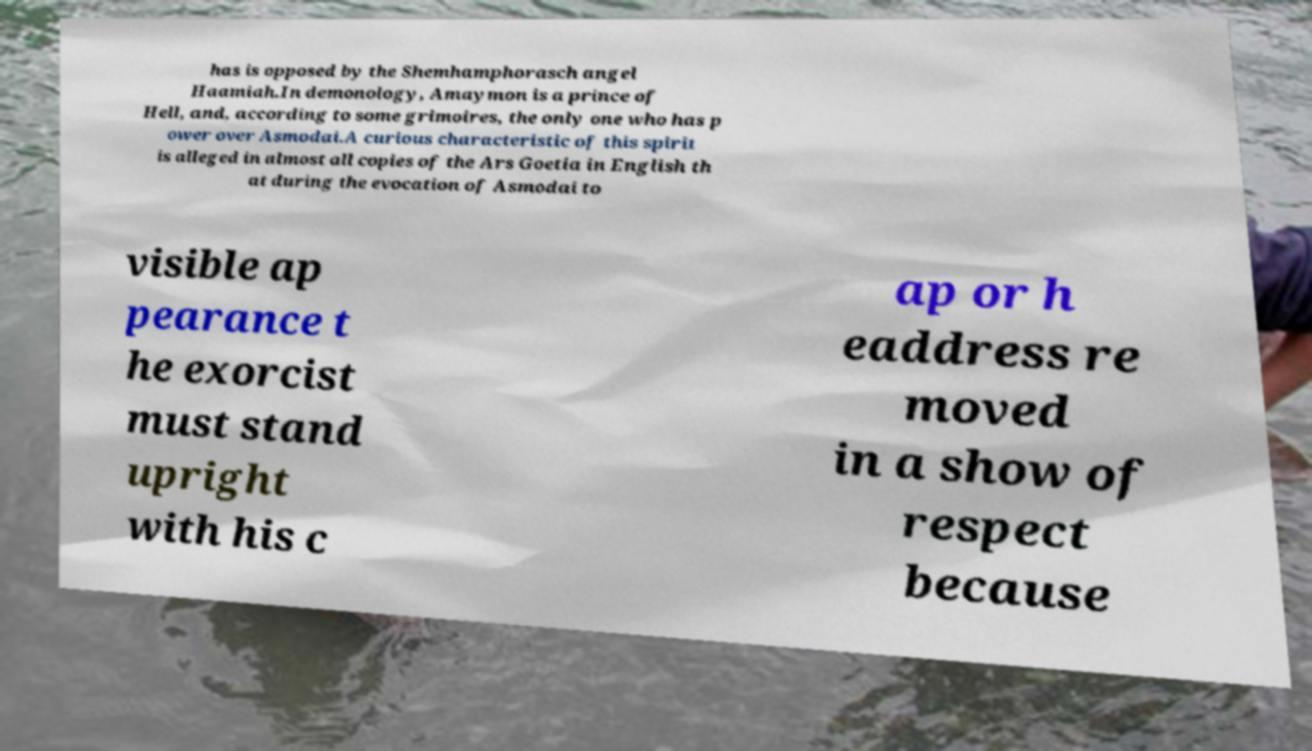I need the written content from this picture converted into text. Can you do that? has is opposed by the Shemhamphorasch angel Haamiah.In demonology, Amaymon is a prince of Hell, and, according to some grimoires, the only one who has p ower over Asmodai.A curious characteristic of this spirit is alleged in almost all copies of the Ars Goetia in English th at during the evocation of Asmodai to visible ap pearance t he exorcist must stand upright with his c ap or h eaddress re moved in a show of respect because 